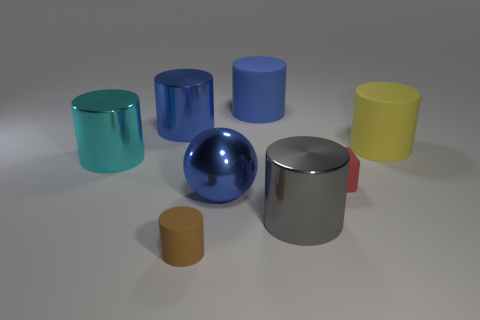Is there a block that is in front of the tiny object on the right side of the gray metallic cylinder? Based on the image provided, there does not appear to be a block directly in front of the small object, which is situated to the right of the gray metallic cylinder. 